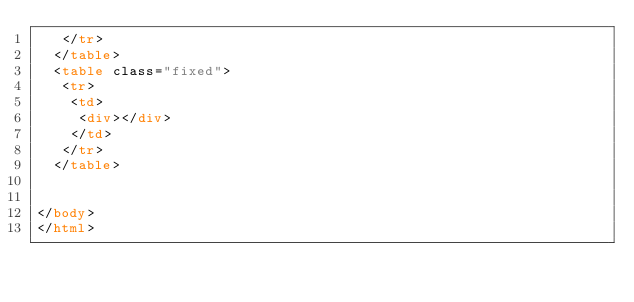Convert code to text. <code><loc_0><loc_0><loc_500><loc_500><_HTML_>   </tr>
  </table>
  <table class="fixed">
   <tr>
    <td>
     <div></div>
    </td>
   </tr>
  </table>


</body>
</html></code> 